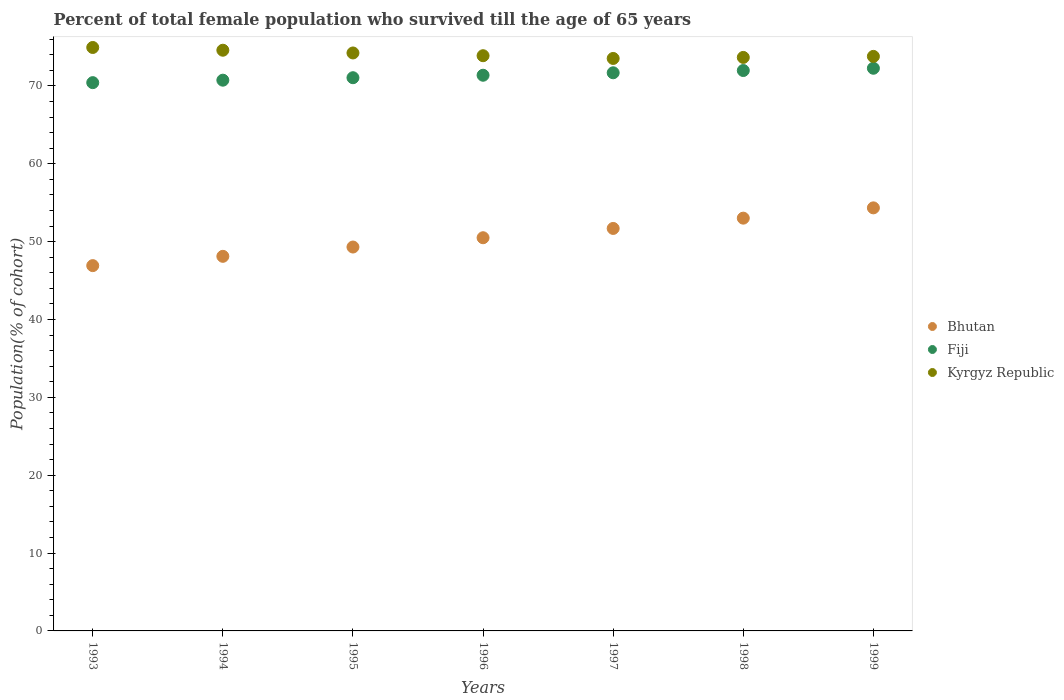How many different coloured dotlines are there?
Your answer should be compact. 3. Is the number of dotlines equal to the number of legend labels?
Your answer should be compact. Yes. What is the percentage of total female population who survived till the age of 65 years in Bhutan in 1999?
Offer a very short reply. 54.33. Across all years, what is the maximum percentage of total female population who survived till the age of 65 years in Fiji?
Give a very brief answer. 72.26. Across all years, what is the minimum percentage of total female population who survived till the age of 65 years in Fiji?
Make the answer very short. 70.41. What is the total percentage of total female population who survived till the age of 65 years in Kyrgyz Republic in the graph?
Keep it short and to the point. 518.57. What is the difference between the percentage of total female population who survived till the age of 65 years in Fiji in 1993 and that in 1997?
Give a very brief answer. -1.27. What is the difference between the percentage of total female population who survived till the age of 65 years in Bhutan in 1993 and the percentage of total female population who survived till the age of 65 years in Kyrgyz Republic in 1998?
Make the answer very short. -26.74. What is the average percentage of total female population who survived till the age of 65 years in Fiji per year?
Offer a very short reply. 71.35. In the year 1995, what is the difference between the percentage of total female population who survived till the age of 65 years in Bhutan and percentage of total female population who survived till the age of 65 years in Kyrgyz Republic?
Make the answer very short. -24.92. What is the ratio of the percentage of total female population who survived till the age of 65 years in Fiji in 1996 to that in 1997?
Make the answer very short. 1. Is the percentage of total female population who survived till the age of 65 years in Kyrgyz Republic in 1993 less than that in 1999?
Your answer should be compact. No. Is the difference between the percentage of total female population who survived till the age of 65 years in Bhutan in 1996 and 1997 greater than the difference between the percentage of total female population who survived till the age of 65 years in Kyrgyz Republic in 1996 and 1997?
Provide a short and direct response. No. What is the difference between the highest and the second highest percentage of total female population who survived till the age of 65 years in Fiji?
Offer a very short reply. 0.29. What is the difference between the highest and the lowest percentage of total female population who survived till the age of 65 years in Kyrgyz Republic?
Provide a short and direct response. 1.41. Is the sum of the percentage of total female population who survived till the age of 65 years in Fiji in 1997 and 1999 greater than the maximum percentage of total female population who survived till the age of 65 years in Bhutan across all years?
Offer a very short reply. Yes. Is it the case that in every year, the sum of the percentage of total female population who survived till the age of 65 years in Bhutan and percentage of total female population who survived till the age of 65 years in Fiji  is greater than the percentage of total female population who survived till the age of 65 years in Kyrgyz Republic?
Make the answer very short. Yes. Does the percentage of total female population who survived till the age of 65 years in Kyrgyz Republic monotonically increase over the years?
Make the answer very short. No. How many years are there in the graph?
Offer a terse response. 7. Does the graph contain grids?
Ensure brevity in your answer.  No. How many legend labels are there?
Give a very brief answer. 3. How are the legend labels stacked?
Offer a very short reply. Vertical. What is the title of the graph?
Ensure brevity in your answer.  Percent of total female population who survived till the age of 65 years. What is the label or title of the X-axis?
Make the answer very short. Years. What is the label or title of the Y-axis?
Ensure brevity in your answer.  Population(% of cohort). What is the Population(% of cohort) in Bhutan in 1993?
Your response must be concise. 46.91. What is the Population(% of cohort) in Fiji in 1993?
Offer a terse response. 70.41. What is the Population(% of cohort) in Kyrgyz Republic in 1993?
Ensure brevity in your answer.  74.93. What is the Population(% of cohort) in Bhutan in 1994?
Provide a short and direct response. 48.11. What is the Population(% of cohort) in Fiji in 1994?
Give a very brief answer. 70.73. What is the Population(% of cohort) of Kyrgyz Republic in 1994?
Your answer should be very brief. 74.58. What is the Population(% of cohort) of Bhutan in 1995?
Provide a short and direct response. 49.3. What is the Population(% of cohort) of Fiji in 1995?
Provide a short and direct response. 71.05. What is the Population(% of cohort) of Kyrgyz Republic in 1995?
Keep it short and to the point. 74.23. What is the Population(% of cohort) of Bhutan in 1996?
Keep it short and to the point. 50.5. What is the Population(% of cohort) of Fiji in 1996?
Offer a very short reply. 71.36. What is the Population(% of cohort) of Kyrgyz Republic in 1996?
Give a very brief answer. 73.87. What is the Population(% of cohort) of Bhutan in 1997?
Ensure brevity in your answer.  51.69. What is the Population(% of cohort) of Fiji in 1997?
Offer a terse response. 71.68. What is the Population(% of cohort) of Kyrgyz Republic in 1997?
Ensure brevity in your answer.  73.52. What is the Population(% of cohort) of Bhutan in 1998?
Provide a succinct answer. 53.01. What is the Population(% of cohort) of Fiji in 1998?
Your answer should be compact. 71.97. What is the Population(% of cohort) of Kyrgyz Republic in 1998?
Provide a succinct answer. 73.65. What is the Population(% of cohort) of Bhutan in 1999?
Offer a very short reply. 54.33. What is the Population(% of cohort) of Fiji in 1999?
Make the answer very short. 72.26. What is the Population(% of cohort) in Kyrgyz Republic in 1999?
Provide a succinct answer. 73.79. Across all years, what is the maximum Population(% of cohort) in Bhutan?
Offer a terse response. 54.33. Across all years, what is the maximum Population(% of cohort) of Fiji?
Make the answer very short. 72.26. Across all years, what is the maximum Population(% of cohort) of Kyrgyz Republic?
Give a very brief answer. 74.93. Across all years, what is the minimum Population(% of cohort) in Bhutan?
Offer a very short reply. 46.91. Across all years, what is the minimum Population(% of cohort) of Fiji?
Provide a succinct answer. 70.41. Across all years, what is the minimum Population(% of cohort) of Kyrgyz Republic?
Offer a very short reply. 73.52. What is the total Population(% of cohort) in Bhutan in the graph?
Ensure brevity in your answer.  353.86. What is the total Population(% of cohort) of Fiji in the graph?
Ensure brevity in your answer.  499.47. What is the total Population(% of cohort) of Kyrgyz Republic in the graph?
Make the answer very short. 518.57. What is the difference between the Population(% of cohort) in Bhutan in 1993 and that in 1994?
Your answer should be very brief. -1.19. What is the difference between the Population(% of cohort) in Fiji in 1993 and that in 1994?
Your response must be concise. -0.32. What is the difference between the Population(% of cohort) of Kyrgyz Republic in 1993 and that in 1994?
Offer a very short reply. 0.35. What is the difference between the Population(% of cohort) of Bhutan in 1993 and that in 1995?
Give a very brief answer. -2.39. What is the difference between the Population(% of cohort) in Fiji in 1993 and that in 1995?
Make the answer very short. -0.63. What is the difference between the Population(% of cohort) of Kyrgyz Republic in 1993 and that in 1995?
Give a very brief answer. 0.7. What is the difference between the Population(% of cohort) of Bhutan in 1993 and that in 1996?
Ensure brevity in your answer.  -3.58. What is the difference between the Population(% of cohort) in Fiji in 1993 and that in 1996?
Your response must be concise. -0.95. What is the difference between the Population(% of cohort) in Kyrgyz Republic in 1993 and that in 1996?
Offer a very short reply. 1.06. What is the difference between the Population(% of cohort) of Bhutan in 1993 and that in 1997?
Your answer should be compact. -4.78. What is the difference between the Population(% of cohort) in Fiji in 1993 and that in 1997?
Keep it short and to the point. -1.27. What is the difference between the Population(% of cohort) in Kyrgyz Republic in 1993 and that in 1997?
Provide a short and direct response. 1.41. What is the difference between the Population(% of cohort) in Bhutan in 1993 and that in 1998?
Offer a very short reply. -6.1. What is the difference between the Population(% of cohort) of Fiji in 1993 and that in 1998?
Provide a succinct answer. -1.56. What is the difference between the Population(% of cohort) in Kyrgyz Republic in 1993 and that in 1998?
Provide a short and direct response. 1.28. What is the difference between the Population(% of cohort) in Bhutan in 1993 and that in 1999?
Your answer should be compact. -7.42. What is the difference between the Population(% of cohort) in Fiji in 1993 and that in 1999?
Provide a succinct answer. -1.85. What is the difference between the Population(% of cohort) of Kyrgyz Republic in 1993 and that in 1999?
Your response must be concise. 1.14. What is the difference between the Population(% of cohort) in Bhutan in 1994 and that in 1995?
Give a very brief answer. -1.19. What is the difference between the Population(% of cohort) in Fiji in 1994 and that in 1995?
Your response must be concise. -0.32. What is the difference between the Population(% of cohort) of Kyrgyz Republic in 1994 and that in 1995?
Your answer should be compact. 0.35. What is the difference between the Population(% of cohort) in Bhutan in 1994 and that in 1996?
Offer a terse response. -2.39. What is the difference between the Population(% of cohort) of Fiji in 1994 and that in 1996?
Your response must be concise. -0.63. What is the difference between the Population(% of cohort) in Kyrgyz Republic in 1994 and that in 1996?
Keep it short and to the point. 0.7. What is the difference between the Population(% of cohort) of Bhutan in 1994 and that in 1997?
Make the answer very short. -3.58. What is the difference between the Population(% of cohort) of Fiji in 1994 and that in 1997?
Offer a terse response. -0.95. What is the difference between the Population(% of cohort) in Kyrgyz Republic in 1994 and that in 1997?
Offer a terse response. 1.06. What is the difference between the Population(% of cohort) in Bhutan in 1994 and that in 1998?
Ensure brevity in your answer.  -4.9. What is the difference between the Population(% of cohort) of Fiji in 1994 and that in 1998?
Offer a terse response. -1.24. What is the difference between the Population(% of cohort) in Kyrgyz Republic in 1994 and that in 1998?
Your response must be concise. 0.92. What is the difference between the Population(% of cohort) in Bhutan in 1994 and that in 1999?
Your answer should be very brief. -6.22. What is the difference between the Population(% of cohort) of Fiji in 1994 and that in 1999?
Ensure brevity in your answer.  -1.53. What is the difference between the Population(% of cohort) of Kyrgyz Republic in 1994 and that in 1999?
Ensure brevity in your answer.  0.79. What is the difference between the Population(% of cohort) of Bhutan in 1995 and that in 1996?
Your answer should be very brief. -1.19. What is the difference between the Population(% of cohort) in Fiji in 1995 and that in 1996?
Ensure brevity in your answer.  -0.32. What is the difference between the Population(% of cohort) of Kyrgyz Republic in 1995 and that in 1996?
Ensure brevity in your answer.  0.35. What is the difference between the Population(% of cohort) in Bhutan in 1995 and that in 1997?
Your response must be concise. -2.39. What is the difference between the Population(% of cohort) in Fiji in 1995 and that in 1997?
Offer a terse response. -0.63. What is the difference between the Population(% of cohort) of Kyrgyz Republic in 1995 and that in 1997?
Ensure brevity in your answer.  0.7. What is the difference between the Population(% of cohort) in Bhutan in 1995 and that in 1998?
Your response must be concise. -3.71. What is the difference between the Population(% of cohort) in Fiji in 1995 and that in 1998?
Your answer should be compact. -0.92. What is the difference between the Population(% of cohort) of Kyrgyz Republic in 1995 and that in 1998?
Keep it short and to the point. 0.57. What is the difference between the Population(% of cohort) of Bhutan in 1995 and that in 1999?
Give a very brief answer. -5.03. What is the difference between the Population(% of cohort) of Fiji in 1995 and that in 1999?
Your answer should be compact. -1.21. What is the difference between the Population(% of cohort) in Kyrgyz Republic in 1995 and that in 1999?
Give a very brief answer. 0.44. What is the difference between the Population(% of cohort) of Bhutan in 1996 and that in 1997?
Make the answer very short. -1.19. What is the difference between the Population(% of cohort) in Fiji in 1996 and that in 1997?
Your answer should be very brief. -0.32. What is the difference between the Population(% of cohort) of Kyrgyz Republic in 1996 and that in 1997?
Your response must be concise. 0.35. What is the difference between the Population(% of cohort) in Bhutan in 1996 and that in 1998?
Your answer should be compact. -2.52. What is the difference between the Population(% of cohort) of Fiji in 1996 and that in 1998?
Offer a very short reply. -0.61. What is the difference between the Population(% of cohort) in Kyrgyz Republic in 1996 and that in 1998?
Offer a terse response. 0.22. What is the difference between the Population(% of cohort) of Bhutan in 1996 and that in 1999?
Offer a very short reply. -3.84. What is the difference between the Population(% of cohort) of Fiji in 1996 and that in 1999?
Make the answer very short. -0.9. What is the difference between the Population(% of cohort) in Kyrgyz Republic in 1996 and that in 1999?
Provide a succinct answer. 0.09. What is the difference between the Population(% of cohort) in Bhutan in 1997 and that in 1998?
Your answer should be compact. -1.32. What is the difference between the Population(% of cohort) of Fiji in 1997 and that in 1998?
Keep it short and to the point. -0.29. What is the difference between the Population(% of cohort) of Kyrgyz Republic in 1997 and that in 1998?
Provide a short and direct response. -0.13. What is the difference between the Population(% of cohort) of Bhutan in 1997 and that in 1999?
Offer a terse response. -2.64. What is the difference between the Population(% of cohort) in Fiji in 1997 and that in 1999?
Make the answer very short. -0.58. What is the difference between the Population(% of cohort) in Kyrgyz Republic in 1997 and that in 1999?
Your response must be concise. -0.26. What is the difference between the Population(% of cohort) in Bhutan in 1998 and that in 1999?
Keep it short and to the point. -1.32. What is the difference between the Population(% of cohort) in Fiji in 1998 and that in 1999?
Give a very brief answer. -0.29. What is the difference between the Population(% of cohort) of Kyrgyz Republic in 1998 and that in 1999?
Give a very brief answer. -0.13. What is the difference between the Population(% of cohort) in Bhutan in 1993 and the Population(% of cohort) in Fiji in 1994?
Your response must be concise. -23.82. What is the difference between the Population(% of cohort) of Bhutan in 1993 and the Population(% of cohort) of Kyrgyz Republic in 1994?
Your answer should be compact. -27.66. What is the difference between the Population(% of cohort) in Fiji in 1993 and the Population(% of cohort) in Kyrgyz Republic in 1994?
Make the answer very short. -4.16. What is the difference between the Population(% of cohort) of Bhutan in 1993 and the Population(% of cohort) of Fiji in 1995?
Offer a very short reply. -24.13. What is the difference between the Population(% of cohort) in Bhutan in 1993 and the Population(% of cohort) in Kyrgyz Republic in 1995?
Your answer should be very brief. -27.31. What is the difference between the Population(% of cohort) of Fiji in 1993 and the Population(% of cohort) of Kyrgyz Republic in 1995?
Keep it short and to the point. -3.81. What is the difference between the Population(% of cohort) of Bhutan in 1993 and the Population(% of cohort) of Fiji in 1996?
Make the answer very short. -24.45. What is the difference between the Population(% of cohort) in Bhutan in 1993 and the Population(% of cohort) in Kyrgyz Republic in 1996?
Your answer should be very brief. -26.96. What is the difference between the Population(% of cohort) in Fiji in 1993 and the Population(% of cohort) in Kyrgyz Republic in 1996?
Your answer should be very brief. -3.46. What is the difference between the Population(% of cohort) of Bhutan in 1993 and the Population(% of cohort) of Fiji in 1997?
Make the answer very short. -24.77. What is the difference between the Population(% of cohort) in Bhutan in 1993 and the Population(% of cohort) in Kyrgyz Republic in 1997?
Ensure brevity in your answer.  -26.61. What is the difference between the Population(% of cohort) of Fiji in 1993 and the Population(% of cohort) of Kyrgyz Republic in 1997?
Offer a terse response. -3.11. What is the difference between the Population(% of cohort) of Bhutan in 1993 and the Population(% of cohort) of Fiji in 1998?
Give a very brief answer. -25.06. What is the difference between the Population(% of cohort) of Bhutan in 1993 and the Population(% of cohort) of Kyrgyz Republic in 1998?
Provide a succinct answer. -26.74. What is the difference between the Population(% of cohort) of Fiji in 1993 and the Population(% of cohort) of Kyrgyz Republic in 1998?
Ensure brevity in your answer.  -3.24. What is the difference between the Population(% of cohort) in Bhutan in 1993 and the Population(% of cohort) in Fiji in 1999?
Ensure brevity in your answer.  -25.35. What is the difference between the Population(% of cohort) of Bhutan in 1993 and the Population(% of cohort) of Kyrgyz Republic in 1999?
Provide a short and direct response. -26.87. What is the difference between the Population(% of cohort) of Fiji in 1993 and the Population(% of cohort) of Kyrgyz Republic in 1999?
Your answer should be compact. -3.37. What is the difference between the Population(% of cohort) of Bhutan in 1994 and the Population(% of cohort) of Fiji in 1995?
Offer a terse response. -22.94. What is the difference between the Population(% of cohort) of Bhutan in 1994 and the Population(% of cohort) of Kyrgyz Republic in 1995?
Your answer should be compact. -26.12. What is the difference between the Population(% of cohort) of Fiji in 1994 and the Population(% of cohort) of Kyrgyz Republic in 1995?
Provide a succinct answer. -3.5. What is the difference between the Population(% of cohort) in Bhutan in 1994 and the Population(% of cohort) in Fiji in 1996?
Provide a succinct answer. -23.26. What is the difference between the Population(% of cohort) in Bhutan in 1994 and the Population(% of cohort) in Kyrgyz Republic in 1996?
Ensure brevity in your answer.  -25.77. What is the difference between the Population(% of cohort) of Fiji in 1994 and the Population(% of cohort) of Kyrgyz Republic in 1996?
Provide a short and direct response. -3.14. What is the difference between the Population(% of cohort) of Bhutan in 1994 and the Population(% of cohort) of Fiji in 1997?
Ensure brevity in your answer.  -23.57. What is the difference between the Population(% of cohort) in Bhutan in 1994 and the Population(% of cohort) in Kyrgyz Republic in 1997?
Make the answer very short. -25.41. What is the difference between the Population(% of cohort) of Fiji in 1994 and the Population(% of cohort) of Kyrgyz Republic in 1997?
Your answer should be compact. -2.79. What is the difference between the Population(% of cohort) of Bhutan in 1994 and the Population(% of cohort) of Fiji in 1998?
Your answer should be very brief. -23.86. What is the difference between the Population(% of cohort) of Bhutan in 1994 and the Population(% of cohort) of Kyrgyz Republic in 1998?
Your answer should be very brief. -25.55. What is the difference between the Population(% of cohort) of Fiji in 1994 and the Population(% of cohort) of Kyrgyz Republic in 1998?
Offer a very short reply. -2.92. What is the difference between the Population(% of cohort) in Bhutan in 1994 and the Population(% of cohort) in Fiji in 1999?
Your answer should be very brief. -24.15. What is the difference between the Population(% of cohort) in Bhutan in 1994 and the Population(% of cohort) in Kyrgyz Republic in 1999?
Your answer should be very brief. -25.68. What is the difference between the Population(% of cohort) in Fiji in 1994 and the Population(% of cohort) in Kyrgyz Republic in 1999?
Keep it short and to the point. -3.06. What is the difference between the Population(% of cohort) in Bhutan in 1995 and the Population(% of cohort) in Fiji in 1996?
Your response must be concise. -22.06. What is the difference between the Population(% of cohort) in Bhutan in 1995 and the Population(% of cohort) in Kyrgyz Republic in 1996?
Ensure brevity in your answer.  -24.57. What is the difference between the Population(% of cohort) in Fiji in 1995 and the Population(% of cohort) in Kyrgyz Republic in 1996?
Make the answer very short. -2.83. What is the difference between the Population(% of cohort) in Bhutan in 1995 and the Population(% of cohort) in Fiji in 1997?
Your response must be concise. -22.38. What is the difference between the Population(% of cohort) in Bhutan in 1995 and the Population(% of cohort) in Kyrgyz Republic in 1997?
Keep it short and to the point. -24.22. What is the difference between the Population(% of cohort) of Fiji in 1995 and the Population(% of cohort) of Kyrgyz Republic in 1997?
Ensure brevity in your answer.  -2.47. What is the difference between the Population(% of cohort) of Bhutan in 1995 and the Population(% of cohort) of Fiji in 1998?
Offer a very short reply. -22.67. What is the difference between the Population(% of cohort) of Bhutan in 1995 and the Population(% of cohort) of Kyrgyz Republic in 1998?
Offer a terse response. -24.35. What is the difference between the Population(% of cohort) in Fiji in 1995 and the Population(% of cohort) in Kyrgyz Republic in 1998?
Give a very brief answer. -2.61. What is the difference between the Population(% of cohort) in Bhutan in 1995 and the Population(% of cohort) in Fiji in 1999?
Ensure brevity in your answer.  -22.96. What is the difference between the Population(% of cohort) in Bhutan in 1995 and the Population(% of cohort) in Kyrgyz Republic in 1999?
Make the answer very short. -24.48. What is the difference between the Population(% of cohort) in Fiji in 1995 and the Population(% of cohort) in Kyrgyz Republic in 1999?
Your answer should be very brief. -2.74. What is the difference between the Population(% of cohort) of Bhutan in 1996 and the Population(% of cohort) of Fiji in 1997?
Ensure brevity in your answer.  -21.18. What is the difference between the Population(% of cohort) of Bhutan in 1996 and the Population(% of cohort) of Kyrgyz Republic in 1997?
Keep it short and to the point. -23.03. What is the difference between the Population(% of cohort) of Fiji in 1996 and the Population(% of cohort) of Kyrgyz Republic in 1997?
Offer a terse response. -2.16. What is the difference between the Population(% of cohort) of Bhutan in 1996 and the Population(% of cohort) of Fiji in 1998?
Provide a succinct answer. -21.48. What is the difference between the Population(% of cohort) in Bhutan in 1996 and the Population(% of cohort) in Kyrgyz Republic in 1998?
Provide a succinct answer. -23.16. What is the difference between the Population(% of cohort) of Fiji in 1996 and the Population(% of cohort) of Kyrgyz Republic in 1998?
Provide a succinct answer. -2.29. What is the difference between the Population(% of cohort) in Bhutan in 1996 and the Population(% of cohort) in Fiji in 1999?
Keep it short and to the point. -21.77. What is the difference between the Population(% of cohort) in Bhutan in 1996 and the Population(% of cohort) in Kyrgyz Republic in 1999?
Ensure brevity in your answer.  -23.29. What is the difference between the Population(% of cohort) in Fiji in 1996 and the Population(% of cohort) in Kyrgyz Republic in 1999?
Provide a succinct answer. -2.42. What is the difference between the Population(% of cohort) of Bhutan in 1997 and the Population(% of cohort) of Fiji in 1998?
Make the answer very short. -20.28. What is the difference between the Population(% of cohort) in Bhutan in 1997 and the Population(% of cohort) in Kyrgyz Republic in 1998?
Offer a terse response. -21.96. What is the difference between the Population(% of cohort) of Fiji in 1997 and the Population(% of cohort) of Kyrgyz Republic in 1998?
Your answer should be compact. -1.97. What is the difference between the Population(% of cohort) in Bhutan in 1997 and the Population(% of cohort) in Fiji in 1999?
Keep it short and to the point. -20.57. What is the difference between the Population(% of cohort) of Bhutan in 1997 and the Population(% of cohort) of Kyrgyz Republic in 1999?
Your answer should be very brief. -22.1. What is the difference between the Population(% of cohort) in Fiji in 1997 and the Population(% of cohort) in Kyrgyz Republic in 1999?
Keep it short and to the point. -2.11. What is the difference between the Population(% of cohort) in Bhutan in 1998 and the Population(% of cohort) in Fiji in 1999?
Keep it short and to the point. -19.25. What is the difference between the Population(% of cohort) of Bhutan in 1998 and the Population(% of cohort) of Kyrgyz Republic in 1999?
Your response must be concise. -20.77. What is the difference between the Population(% of cohort) in Fiji in 1998 and the Population(% of cohort) in Kyrgyz Republic in 1999?
Your answer should be compact. -1.82. What is the average Population(% of cohort) in Bhutan per year?
Ensure brevity in your answer.  50.55. What is the average Population(% of cohort) of Fiji per year?
Give a very brief answer. 71.35. What is the average Population(% of cohort) of Kyrgyz Republic per year?
Your answer should be very brief. 74.08. In the year 1993, what is the difference between the Population(% of cohort) in Bhutan and Population(% of cohort) in Fiji?
Offer a very short reply. -23.5. In the year 1993, what is the difference between the Population(% of cohort) of Bhutan and Population(% of cohort) of Kyrgyz Republic?
Offer a very short reply. -28.02. In the year 1993, what is the difference between the Population(% of cohort) in Fiji and Population(% of cohort) in Kyrgyz Republic?
Offer a terse response. -4.52. In the year 1994, what is the difference between the Population(% of cohort) of Bhutan and Population(% of cohort) of Fiji?
Ensure brevity in your answer.  -22.62. In the year 1994, what is the difference between the Population(% of cohort) of Bhutan and Population(% of cohort) of Kyrgyz Republic?
Your answer should be very brief. -26.47. In the year 1994, what is the difference between the Population(% of cohort) in Fiji and Population(% of cohort) in Kyrgyz Republic?
Provide a succinct answer. -3.85. In the year 1995, what is the difference between the Population(% of cohort) in Bhutan and Population(% of cohort) in Fiji?
Your response must be concise. -21.75. In the year 1995, what is the difference between the Population(% of cohort) of Bhutan and Population(% of cohort) of Kyrgyz Republic?
Your response must be concise. -24.92. In the year 1995, what is the difference between the Population(% of cohort) of Fiji and Population(% of cohort) of Kyrgyz Republic?
Your answer should be very brief. -3.18. In the year 1996, what is the difference between the Population(% of cohort) of Bhutan and Population(% of cohort) of Fiji?
Provide a succinct answer. -20.87. In the year 1996, what is the difference between the Population(% of cohort) in Bhutan and Population(% of cohort) in Kyrgyz Republic?
Make the answer very short. -23.38. In the year 1996, what is the difference between the Population(% of cohort) of Fiji and Population(% of cohort) of Kyrgyz Republic?
Provide a short and direct response. -2.51. In the year 1997, what is the difference between the Population(% of cohort) of Bhutan and Population(% of cohort) of Fiji?
Your answer should be very brief. -19.99. In the year 1997, what is the difference between the Population(% of cohort) of Bhutan and Population(% of cohort) of Kyrgyz Republic?
Provide a succinct answer. -21.83. In the year 1997, what is the difference between the Population(% of cohort) in Fiji and Population(% of cohort) in Kyrgyz Republic?
Ensure brevity in your answer.  -1.84. In the year 1998, what is the difference between the Population(% of cohort) of Bhutan and Population(% of cohort) of Fiji?
Give a very brief answer. -18.96. In the year 1998, what is the difference between the Population(% of cohort) in Bhutan and Population(% of cohort) in Kyrgyz Republic?
Provide a succinct answer. -20.64. In the year 1998, what is the difference between the Population(% of cohort) in Fiji and Population(% of cohort) in Kyrgyz Republic?
Provide a succinct answer. -1.68. In the year 1999, what is the difference between the Population(% of cohort) of Bhutan and Population(% of cohort) of Fiji?
Provide a short and direct response. -17.93. In the year 1999, what is the difference between the Population(% of cohort) of Bhutan and Population(% of cohort) of Kyrgyz Republic?
Your answer should be very brief. -19.45. In the year 1999, what is the difference between the Population(% of cohort) of Fiji and Population(% of cohort) of Kyrgyz Republic?
Keep it short and to the point. -1.53. What is the ratio of the Population(% of cohort) in Bhutan in 1993 to that in 1994?
Offer a very short reply. 0.98. What is the ratio of the Population(% of cohort) of Fiji in 1993 to that in 1994?
Provide a short and direct response. 1. What is the ratio of the Population(% of cohort) of Kyrgyz Republic in 1993 to that in 1994?
Give a very brief answer. 1. What is the ratio of the Population(% of cohort) in Bhutan in 1993 to that in 1995?
Provide a succinct answer. 0.95. What is the ratio of the Population(% of cohort) of Fiji in 1993 to that in 1995?
Offer a very short reply. 0.99. What is the ratio of the Population(% of cohort) in Kyrgyz Republic in 1993 to that in 1995?
Make the answer very short. 1.01. What is the ratio of the Population(% of cohort) of Bhutan in 1993 to that in 1996?
Provide a short and direct response. 0.93. What is the ratio of the Population(% of cohort) of Fiji in 1993 to that in 1996?
Make the answer very short. 0.99. What is the ratio of the Population(% of cohort) in Kyrgyz Republic in 1993 to that in 1996?
Offer a terse response. 1.01. What is the ratio of the Population(% of cohort) in Bhutan in 1993 to that in 1997?
Provide a short and direct response. 0.91. What is the ratio of the Population(% of cohort) of Fiji in 1993 to that in 1997?
Provide a succinct answer. 0.98. What is the ratio of the Population(% of cohort) in Kyrgyz Republic in 1993 to that in 1997?
Your response must be concise. 1.02. What is the ratio of the Population(% of cohort) in Bhutan in 1993 to that in 1998?
Your answer should be very brief. 0.89. What is the ratio of the Population(% of cohort) of Fiji in 1993 to that in 1998?
Your answer should be very brief. 0.98. What is the ratio of the Population(% of cohort) in Kyrgyz Republic in 1993 to that in 1998?
Provide a short and direct response. 1.02. What is the ratio of the Population(% of cohort) of Bhutan in 1993 to that in 1999?
Offer a very short reply. 0.86. What is the ratio of the Population(% of cohort) of Fiji in 1993 to that in 1999?
Your answer should be compact. 0.97. What is the ratio of the Population(% of cohort) of Kyrgyz Republic in 1993 to that in 1999?
Give a very brief answer. 1.02. What is the ratio of the Population(% of cohort) in Bhutan in 1994 to that in 1995?
Your answer should be compact. 0.98. What is the ratio of the Population(% of cohort) of Fiji in 1994 to that in 1995?
Keep it short and to the point. 1. What is the ratio of the Population(% of cohort) of Kyrgyz Republic in 1994 to that in 1995?
Your answer should be very brief. 1. What is the ratio of the Population(% of cohort) of Bhutan in 1994 to that in 1996?
Offer a terse response. 0.95. What is the ratio of the Population(% of cohort) in Fiji in 1994 to that in 1996?
Provide a succinct answer. 0.99. What is the ratio of the Population(% of cohort) in Kyrgyz Republic in 1994 to that in 1996?
Keep it short and to the point. 1.01. What is the ratio of the Population(% of cohort) of Bhutan in 1994 to that in 1997?
Your response must be concise. 0.93. What is the ratio of the Population(% of cohort) of Fiji in 1994 to that in 1997?
Your answer should be very brief. 0.99. What is the ratio of the Population(% of cohort) in Kyrgyz Republic in 1994 to that in 1997?
Provide a short and direct response. 1.01. What is the ratio of the Population(% of cohort) in Bhutan in 1994 to that in 1998?
Your response must be concise. 0.91. What is the ratio of the Population(% of cohort) in Fiji in 1994 to that in 1998?
Offer a very short reply. 0.98. What is the ratio of the Population(% of cohort) in Kyrgyz Republic in 1994 to that in 1998?
Give a very brief answer. 1.01. What is the ratio of the Population(% of cohort) in Bhutan in 1994 to that in 1999?
Make the answer very short. 0.89. What is the ratio of the Population(% of cohort) in Fiji in 1994 to that in 1999?
Keep it short and to the point. 0.98. What is the ratio of the Population(% of cohort) in Kyrgyz Republic in 1994 to that in 1999?
Provide a succinct answer. 1.01. What is the ratio of the Population(% of cohort) in Bhutan in 1995 to that in 1996?
Make the answer very short. 0.98. What is the ratio of the Population(% of cohort) in Fiji in 1995 to that in 1996?
Make the answer very short. 1. What is the ratio of the Population(% of cohort) in Kyrgyz Republic in 1995 to that in 1996?
Keep it short and to the point. 1. What is the ratio of the Population(% of cohort) of Bhutan in 1995 to that in 1997?
Offer a very short reply. 0.95. What is the ratio of the Population(% of cohort) of Kyrgyz Republic in 1995 to that in 1997?
Your answer should be very brief. 1.01. What is the ratio of the Population(% of cohort) in Fiji in 1995 to that in 1998?
Offer a very short reply. 0.99. What is the ratio of the Population(% of cohort) in Bhutan in 1995 to that in 1999?
Provide a short and direct response. 0.91. What is the ratio of the Population(% of cohort) of Fiji in 1995 to that in 1999?
Make the answer very short. 0.98. What is the ratio of the Population(% of cohort) in Bhutan in 1996 to that in 1997?
Offer a very short reply. 0.98. What is the ratio of the Population(% of cohort) of Kyrgyz Republic in 1996 to that in 1997?
Your answer should be compact. 1. What is the ratio of the Population(% of cohort) of Bhutan in 1996 to that in 1998?
Your answer should be very brief. 0.95. What is the ratio of the Population(% of cohort) in Bhutan in 1996 to that in 1999?
Provide a succinct answer. 0.93. What is the ratio of the Population(% of cohort) in Fiji in 1996 to that in 1999?
Keep it short and to the point. 0.99. What is the ratio of the Population(% of cohort) of Kyrgyz Republic in 1996 to that in 1999?
Give a very brief answer. 1. What is the ratio of the Population(% of cohort) in Bhutan in 1997 to that in 1998?
Offer a very short reply. 0.98. What is the ratio of the Population(% of cohort) in Fiji in 1997 to that in 1998?
Make the answer very short. 1. What is the ratio of the Population(% of cohort) in Bhutan in 1997 to that in 1999?
Give a very brief answer. 0.95. What is the ratio of the Population(% of cohort) in Fiji in 1997 to that in 1999?
Offer a very short reply. 0.99. What is the ratio of the Population(% of cohort) in Kyrgyz Republic in 1997 to that in 1999?
Your answer should be very brief. 1. What is the ratio of the Population(% of cohort) in Bhutan in 1998 to that in 1999?
Make the answer very short. 0.98. What is the ratio of the Population(% of cohort) of Kyrgyz Republic in 1998 to that in 1999?
Offer a very short reply. 1. What is the difference between the highest and the second highest Population(% of cohort) of Bhutan?
Give a very brief answer. 1.32. What is the difference between the highest and the second highest Population(% of cohort) of Fiji?
Give a very brief answer. 0.29. What is the difference between the highest and the second highest Population(% of cohort) of Kyrgyz Republic?
Provide a succinct answer. 0.35. What is the difference between the highest and the lowest Population(% of cohort) in Bhutan?
Your answer should be compact. 7.42. What is the difference between the highest and the lowest Population(% of cohort) in Fiji?
Make the answer very short. 1.85. What is the difference between the highest and the lowest Population(% of cohort) of Kyrgyz Republic?
Your answer should be compact. 1.41. 